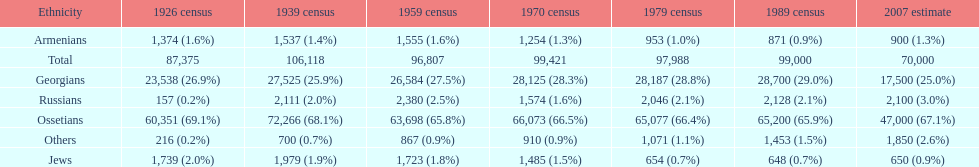What was the first census that saw a russian population of over 2,000? 1939 census. 